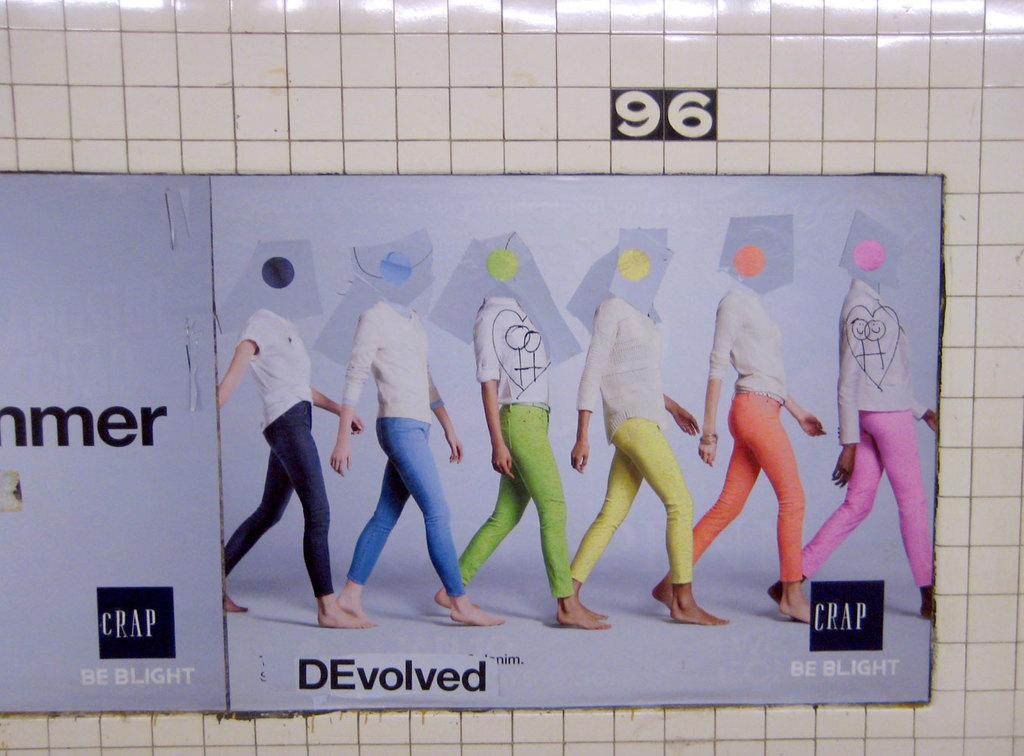What is located in the center of the image? There are posters in the center of the image. Where are the posters placed? The posters are on a wall. What can be seen on the posters? There is text written on the posters. What is the color of the wall where the posters are placed? The wall is white in color. Can you hear the dogs barking in the image? There are no dogs or sounds present in the image, so it is not possible to hear any barking. 